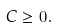<formula> <loc_0><loc_0><loc_500><loc_500>C \geq 0 .</formula> 